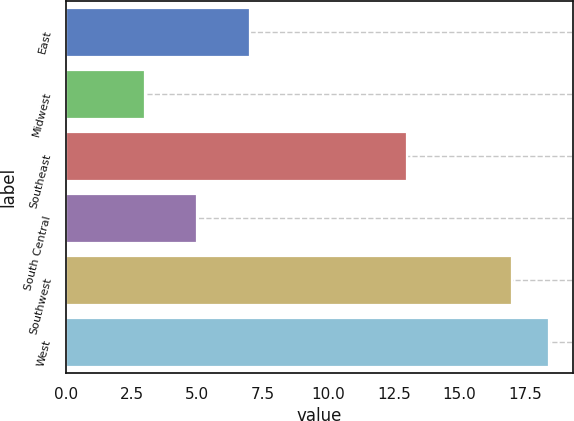Convert chart to OTSL. <chart><loc_0><loc_0><loc_500><loc_500><bar_chart><fcel>East<fcel>Midwest<fcel>Southeast<fcel>South Central<fcel>Southwest<fcel>West<nl><fcel>7<fcel>3<fcel>13<fcel>5<fcel>17<fcel>18.4<nl></chart> 